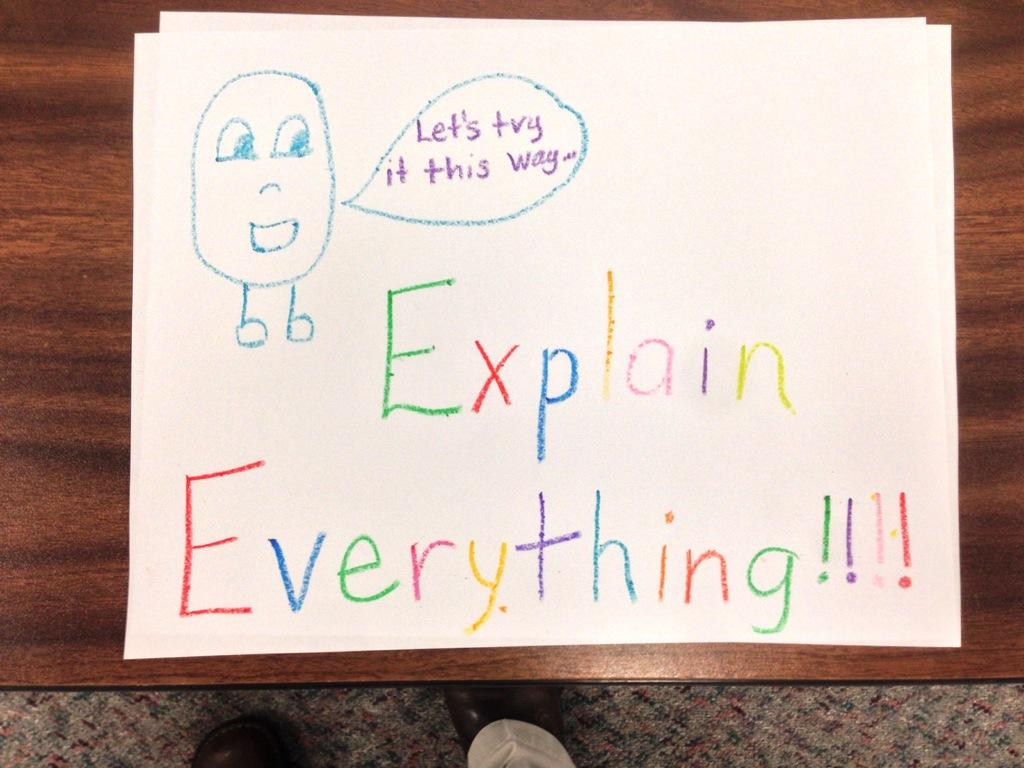<image>
Present a compact description of the photo's key features. A sign written in crayon says to explain everything. 